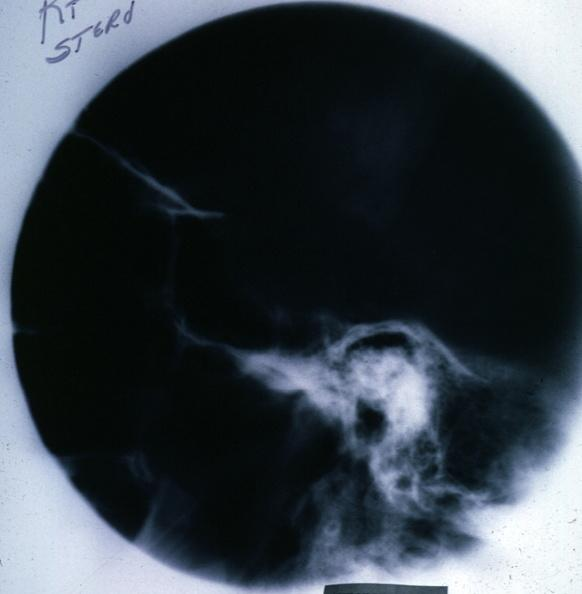what is present?
Answer the question using a single word or phrase. Endocrine 